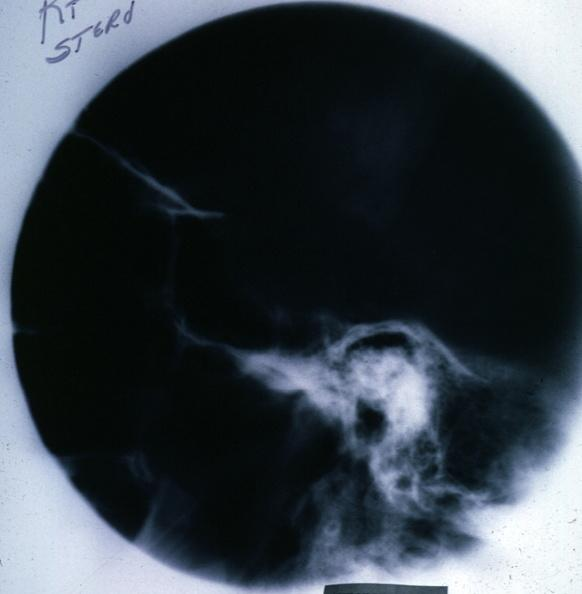what is present?
Answer the question using a single word or phrase. Endocrine 